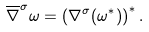<formula> <loc_0><loc_0><loc_500><loc_500>\overline { \nabla } ^ { \sigma } \omega = \left ( \nabla ^ { \sigma } ( \omega ^ { * } ) \right ) ^ { * } .</formula> 